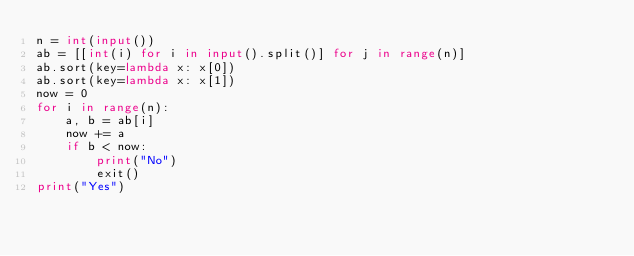Convert code to text. <code><loc_0><loc_0><loc_500><loc_500><_Python_>n = int(input())
ab = [[int(i) for i in input().split()] for j in range(n)]
ab.sort(key=lambda x: x[0])
ab.sort(key=lambda x: x[1])
now = 0
for i in range(n):
    a, b = ab[i]
    now += a
    if b < now:
        print("No")
        exit()
print("Yes")</code> 